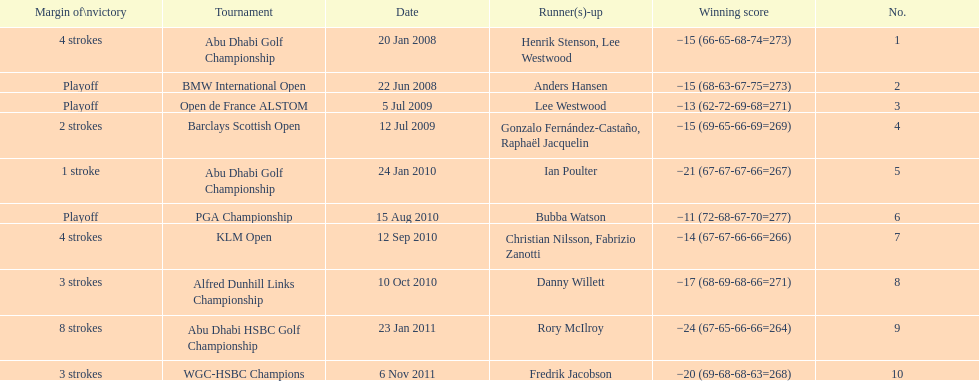Who had the top score in the pga championship? Bubba Watson. 